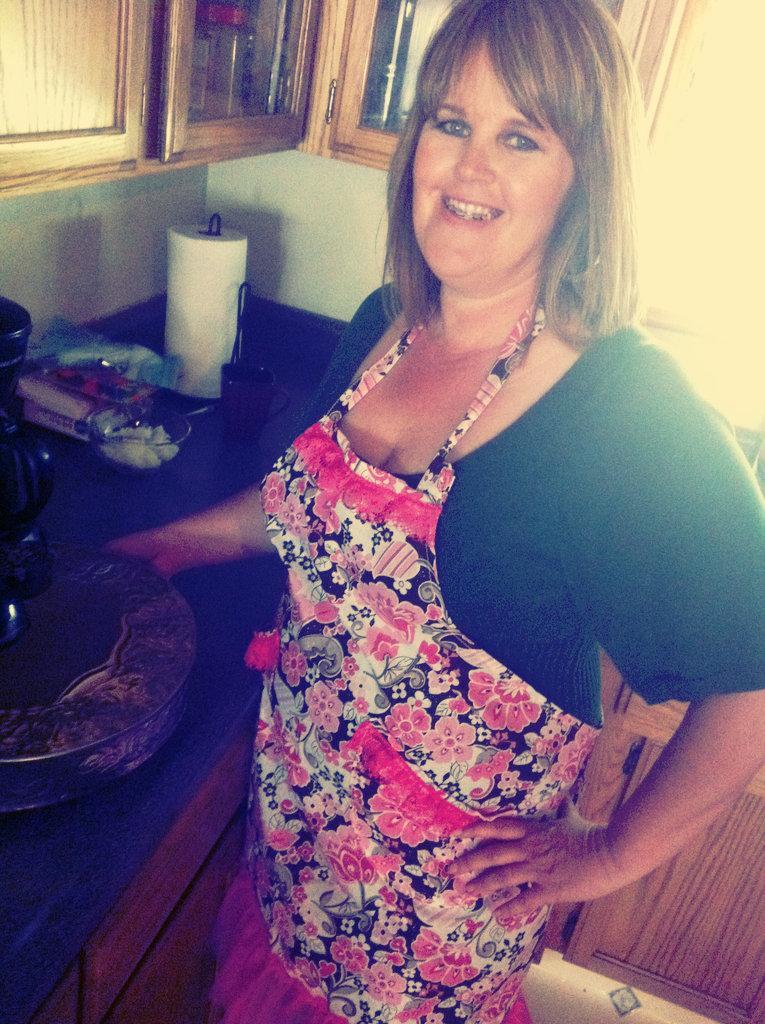How would you summarize this image in a sentence or two? In this picture there is a woman standing and smiling. There is a cup, tissue roller and objects on the table. At the top there are cupboards. At the bottom there are cupboards. 